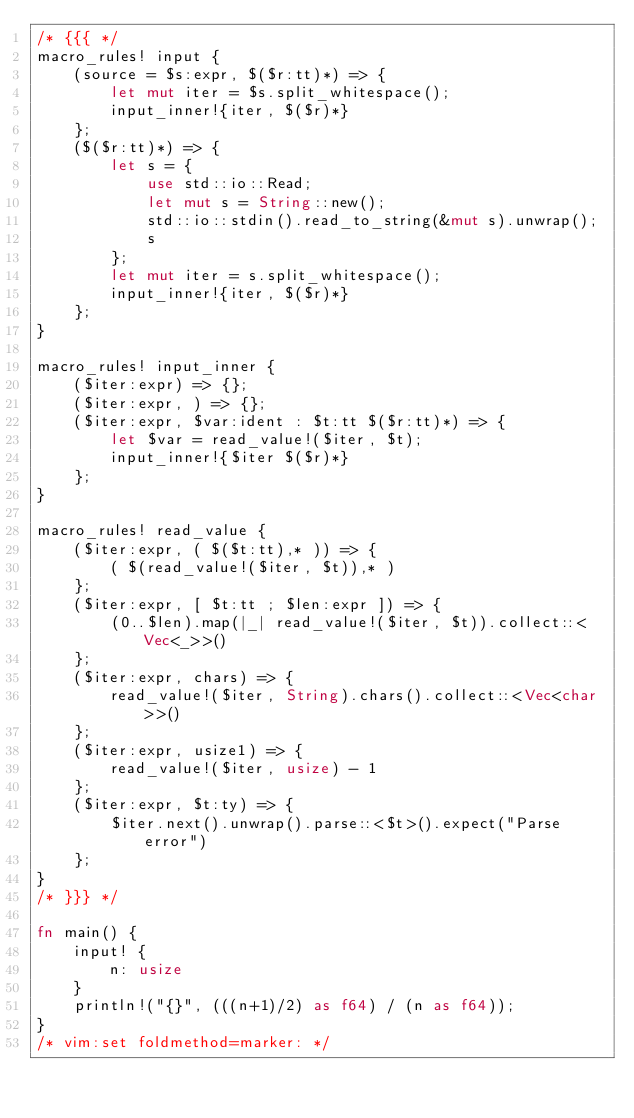<code> <loc_0><loc_0><loc_500><loc_500><_Rust_>/* {{{ */
macro_rules! input {
    (source = $s:expr, $($r:tt)*) => {
        let mut iter = $s.split_whitespace();
        input_inner!{iter, $($r)*}
    };
    ($($r:tt)*) => {
        let s = {
            use std::io::Read;
            let mut s = String::new();
            std::io::stdin().read_to_string(&mut s).unwrap();
            s
        };
        let mut iter = s.split_whitespace();
        input_inner!{iter, $($r)*}
    };
}

macro_rules! input_inner {
    ($iter:expr) => {};
    ($iter:expr, ) => {};
    ($iter:expr, $var:ident : $t:tt $($r:tt)*) => {
        let $var = read_value!($iter, $t);
        input_inner!{$iter $($r)*}
    };
}

macro_rules! read_value {
    ($iter:expr, ( $($t:tt),* )) => {
        ( $(read_value!($iter, $t)),* )
    };
    ($iter:expr, [ $t:tt ; $len:expr ]) => {
        (0..$len).map(|_| read_value!($iter, $t)).collect::<Vec<_>>()
    };
    ($iter:expr, chars) => {
        read_value!($iter, String).chars().collect::<Vec<char>>()
    };
    ($iter:expr, usize1) => {
        read_value!($iter, usize) - 1
    };
    ($iter:expr, $t:ty) => {
        $iter.next().unwrap().parse::<$t>().expect("Parse error")
    };
}
/* }}} */

fn main() {
    input! {
        n: usize
    }
    println!("{}", (((n+1)/2) as f64) / (n as f64));
}
/* vim:set foldmethod=marker: */
</code> 